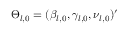<formula> <loc_0><loc_0><loc_500><loc_500>\Theta _ { l , 0 } = ( \beta _ { l , 0 } , \gamma _ { l , 0 } , \nu _ { l , 0 } ) ^ { \prime }</formula> 